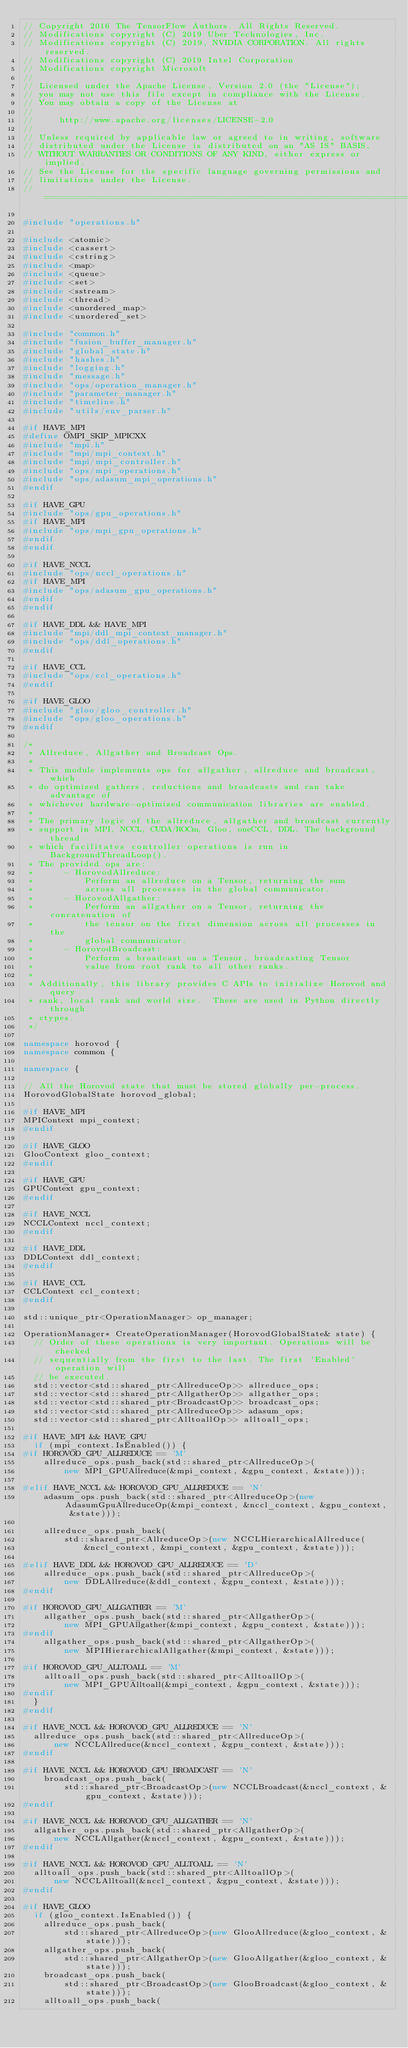<code> <loc_0><loc_0><loc_500><loc_500><_C++_>// Copyright 2016 The TensorFlow Authors. All Rights Reserved.
// Modifications copyright (C) 2019 Uber Technologies, Inc.
// Modifications copyright (C) 2019, NVIDIA CORPORATION. All rights reserved.
// Modifications copyright (C) 2019 Intel Corporation
// Modifications copyright Microsoft
//
// Licensed under the Apache License, Version 2.0 (the "License");
// you may not use this file except in compliance with the License.
// You may obtain a copy of the License at
//
//     http://www.apache.org/licenses/LICENSE-2.0
//
// Unless required by applicable law or agreed to in writing, software
// distributed under the License is distributed on an "AS IS" BASIS,
// WITHOUT WARRANTIES OR CONDITIONS OF ANY KIND, either express or implied.
// See the License for the specific language governing permissions and
// limitations under the License.
// =============================================================================

#include "operations.h"

#include <atomic>
#include <cassert>
#include <cstring>
#include <map>
#include <queue>
#include <set>
#include <sstream>
#include <thread>
#include <unordered_map>
#include <unordered_set>

#include "common.h"
#include "fusion_buffer_manager.h"
#include "global_state.h"
#include "hashes.h"
#include "logging.h"
#include "message.h"
#include "ops/operation_manager.h"
#include "parameter_manager.h"
#include "timeline.h"
#include "utils/env_parser.h"

#if HAVE_MPI
#define OMPI_SKIP_MPICXX
#include "mpi.h"
#include "mpi/mpi_context.h"
#include "mpi/mpi_controller.h"
#include "ops/mpi_operations.h"
#include "ops/adasum_mpi_operations.h"
#endif

#if HAVE_GPU
#include "ops/gpu_operations.h"
#if HAVE_MPI
#include "ops/mpi_gpu_operations.h"
#endif
#endif

#if HAVE_NCCL
#include "ops/nccl_operations.h"
#if HAVE_MPI
#include "ops/adasum_gpu_operations.h"
#endif
#endif

#if HAVE_DDL && HAVE_MPI
#include "mpi/ddl_mpi_context_manager.h"
#include "ops/ddl_operations.h"
#endif

#if HAVE_CCL
#include "ops/ccl_operations.h"
#endif

#if HAVE_GLOO
#include "gloo/gloo_controller.h"
#include "ops/gloo_operations.h"
#endif

/*
 * Allreduce, Allgather and Broadcast Ops.
 *
 * This module implements ops for allgather, allreduce and broadcast, which
 * do optimized gathers, reductions and broadcasts and can take advantage of
 * whichever hardware-optimized communication libraries are enabled.
 *
 * The primary logic of the allreduce, allgather and broadcast currently
 * support in MPI, NCCL, CUDA/ROCm, Gloo, oneCCL, DDL. The background thread
 * which facilitates controller operations is run in BackgroundThreadLoop().
 * The provided ops are:
 *      - HorovodAllreduce:
 *          Perform an allreduce on a Tensor, returning the sum
 *          across all processes in the global communicator.
 *      - HorovodAllgather:
 *          Perform an allgather on a Tensor, returning the concatenation of
 *          the tensor on the first dimension across all processes in the
 *          global communicator.
 *      - HorovodBroadcast:
 *          Perform a broadcast on a Tensor, broadcasting Tensor
 *          value from root rank to all other ranks.
 *
 * Additionally, this library provides C APIs to initialize Horovod and query
 * rank, local rank and world size.  These are used in Python directly through
 * ctypes.
 */

namespace horovod {
namespace common {

namespace {

// All the Horovod state that must be stored globally per-process.
HorovodGlobalState horovod_global;

#if HAVE_MPI
MPIContext mpi_context;
#endif

#if HAVE_GLOO
GlooContext gloo_context;
#endif

#if HAVE_GPU
GPUContext gpu_context;
#endif

#if HAVE_NCCL
NCCLContext nccl_context;
#endif

#if HAVE_DDL
DDLContext ddl_context;
#endif

#if HAVE_CCL
CCLContext ccl_context;
#endif

std::unique_ptr<OperationManager> op_manager;

OperationManager* CreateOperationManager(HorovodGlobalState& state) {
  // Order of these operations is very important. Operations will be checked
  // sequentially from the first to the last. The first 'Enabled' operation will
  // be executed.
  std::vector<std::shared_ptr<AllreduceOp>> allreduce_ops;
  std::vector<std::shared_ptr<AllgatherOp>> allgather_ops;
  std::vector<std::shared_ptr<BroadcastOp>> broadcast_ops;
  std::vector<std::shared_ptr<AllreduceOp>> adasum_ops;
  std::vector<std::shared_ptr<AlltoallOp>> alltoall_ops;

#if HAVE_MPI && HAVE_GPU
  if (mpi_context.IsEnabled()) {
#if HOROVOD_GPU_ALLREDUCE == 'M'
    allreduce_ops.push_back(std::shared_ptr<AllreduceOp>(
        new MPI_GPUAllreduce(&mpi_context, &gpu_context, &state)));

#elif HAVE_NCCL && HOROVOD_GPU_ALLREDUCE == 'N'
    adasum_ops.push_back(std::shared_ptr<AllreduceOp>(new AdasumGpuAllreduceOp(&mpi_context, &nccl_context, &gpu_context, &state)));

    allreduce_ops.push_back(
        std::shared_ptr<AllreduceOp>(new NCCLHierarchicalAllreduce(
            &nccl_context, &mpi_context, &gpu_context, &state)));

#elif HAVE_DDL && HOROVOD_GPU_ALLREDUCE == 'D'
    allreduce_ops.push_back(std::shared_ptr<AllreduceOp>(
        new DDLAllreduce(&ddl_context, &gpu_context, &state)));
#endif

#if HOROVOD_GPU_ALLGATHER == 'M'
    allgather_ops.push_back(std::shared_ptr<AllgatherOp>(
        new MPI_GPUAllgather(&mpi_context, &gpu_context, &state)));
#endif
    allgather_ops.push_back(std::shared_ptr<AllgatherOp>(
        new MPIHierarchicalAllgather(&mpi_context, &state)));

#if HOROVOD_GPU_ALLTOALL == 'M'
    alltoall_ops.push_back(std::shared_ptr<AlltoallOp>(
        new MPI_GPUAlltoall(&mpi_context, &gpu_context, &state)));
#endif
  }
#endif

#if HAVE_NCCL && HOROVOD_GPU_ALLREDUCE == 'N'
  allreduce_ops.push_back(std::shared_ptr<AllreduceOp>(
      new NCCLAllreduce(&nccl_context, &gpu_context, &state)));
#endif

#if HAVE_NCCL && HOROVOD_GPU_BROADCAST == 'N'
    broadcast_ops.push_back(
        std::shared_ptr<BroadcastOp>(new NCCLBroadcast(&nccl_context, &gpu_context, &state)));
#endif

#if HAVE_NCCL && HOROVOD_GPU_ALLGATHER == 'N'
  allgather_ops.push_back(std::shared_ptr<AllgatherOp>(
      new NCCLAllgather(&nccl_context, &gpu_context, &state)));
#endif

#if HAVE_NCCL && HOROVOD_GPU_ALLTOALL == 'N'
  alltoall_ops.push_back(std::shared_ptr<AlltoallOp>(
      new NCCLAlltoall(&nccl_context, &gpu_context, &state)));
#endif

#if HAVE_GLOO
  if (gloo_context.IsEnabled()) {
    allreduce_ops.push_back(
        std::shared_ptr<AllreduceOp>(new GlooAllreduce(&gloo_context, &state)));
    allgather_ops.push_back(
        std::shared_ptr<AllgatherOp>(new GlooAllgather(&gloo_context, &state)));
    broadcast_ops.push_back(
        std::shared_ptr<BroadcastOp>(new GlooBroadcast(&gloo_context, &state)));
    alltoall_ops.push_back(</code> 